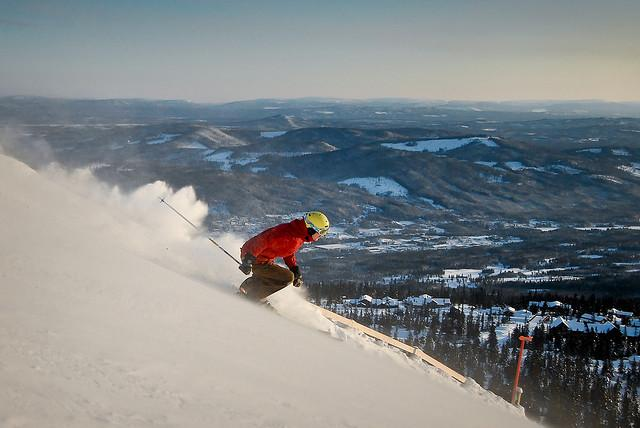What type of region is the man visiting?

Choices:
A) desert
B) mountain
C) tropical
D) aquatic mountain 